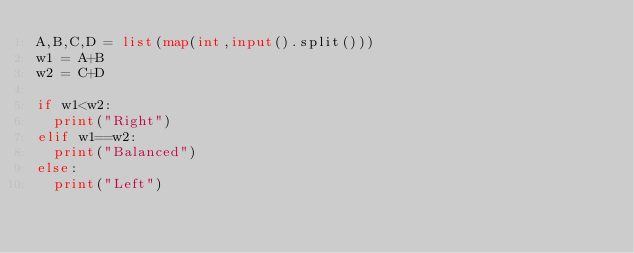<code> <loc_0><loc_0><loc_500><loc_500><_Python_>A,B,C,D = list(map(int,input().split()))
w1 = A+B
w2 = C+D

if w1<w2:
  print("Right")
elif w1==w2:
  print("Balanced")
else:
  print("Left")</code> 